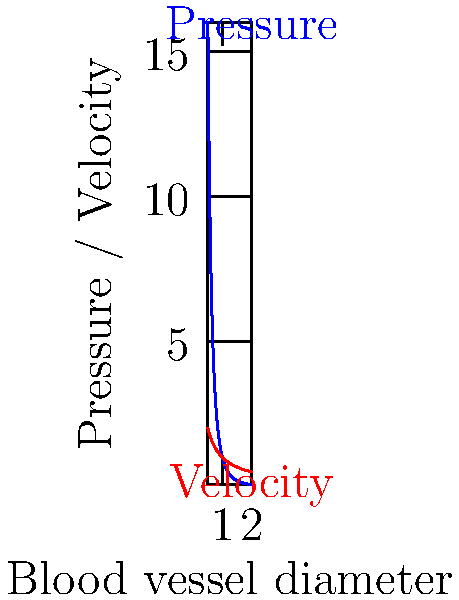As a medical journalist investigating cardiovascular health, you've come across a study on blood flow dynamics. The graph shows the relationship between blood vessel diameter and both pressure and velocity. Based on this information, how does the pressure change as the blood vessel diameter decreases, and what implications might this have for patients with narrowed arteries? To answer this question, let's analyze the graph step-by-step:

1. Observe the blue curve representing pressure:
   - As the vessel diameter decreases (moving left on the x-axis), the pressure increases dramatically.
   - The relationship appears to be inverse and non-linear.

2. Mathematical relationship:
   - The pressure curve closely resembles an inverse fourth power relationship: $P \propto \frac{1}{d^4}$, where $P$ is pressure and $d$ is diameter.

3. Poiseuille's law:
   - This relationship is consistent with Poiseuille's law, which states that pressure drop ($\Delta P$) in a pipe is inversely proportional to the fourth power of the radius: $\Delta P = \frac{8\mu LQ}{\pi r^4}$
   - Where $\mu$ is fluid viscosity, $L$ is pipe length, $Q$ is flow rate, and $r$ is radius.

4. Implications for narrowed arteries:
   - As arteries narrow (e.g., due to atherosclerosis), the pressure increases significantly.
   - This can lead to hypertension and increased stress on the arterial walls.
   - The heart must work harder to pump blood through narrowed vessels, potentially leading to heart strain.

5. Velocity consideration:
   - Note that velocity (red curve) increases as diameter decreases, but not as dramatically as pressure.
   - This is due to the continuity equation: $A_1v_1 = A_2v_2$, where $A$ is cross-sectional area and $v$ is velocity.

In summary, as blood vessel diameter decreases, pressure increases dramatically (proportional to $\frac{1}{d^4}$), which can have serious implications for cardiovascular health in patients with narrowed arteries.
Answer: Pressure increases inversely with the fourth power of diameter ($P \propto \frac{1}{d^4}$), significantly raising cardiovascular risks in narrowed arteries. 